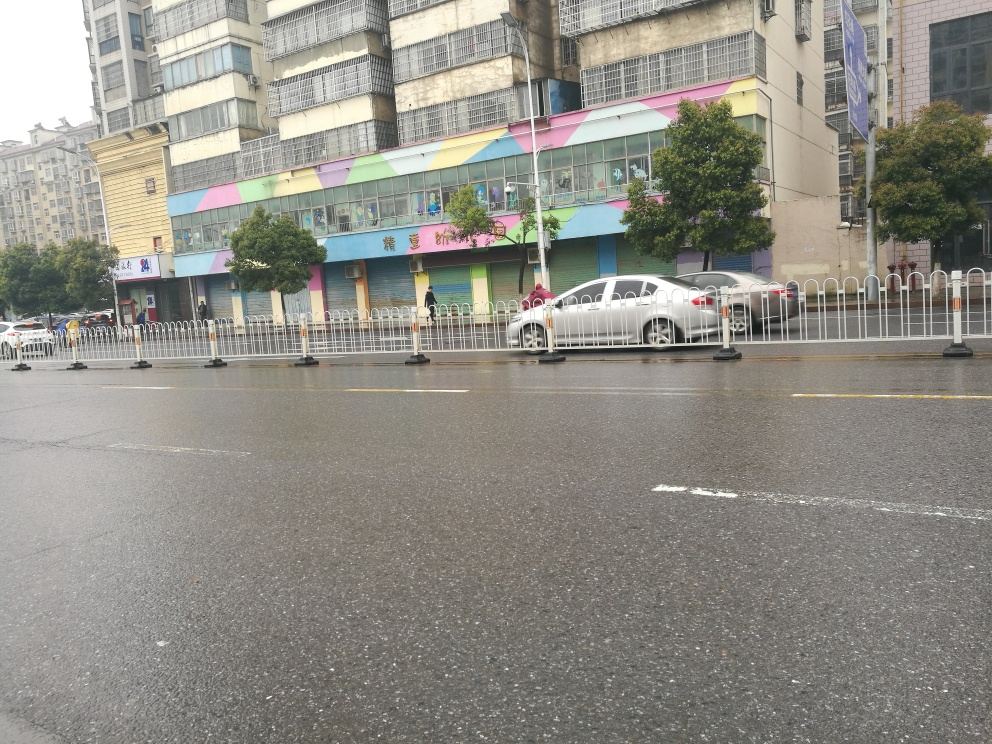Describe the time of day this photo might have been taken. Considering the diffuse light and the lack of shadows, it seems the photo was taken on a cloudy day which makes it difficult to ascertain the exact time. However, the presence of cars and the overall visibility suggest it might be during the daytime. 